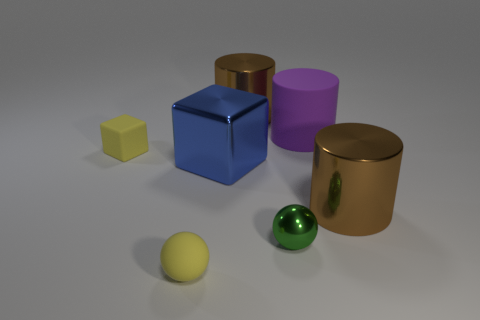What color is the large object that is left of the brown cylinder behind the large brown metallic thing that is in front of the large blue metal object?
Provide a short and direct response. Blue. Is there another purple thing that has the same shape as the purple rubber thing?
Give a very brief answer. No. What number of small red rubber blocks are there?
Give a very brief answer. 0. What is the shape of the large matte thing?
Ensure brevity in your answer.  Cylinder. What number of yellow rubber objects are the same size as the purple thing?
Ensure brevity in your answer.  0. Do the big purple rubber thing and the large blue metallic object have the same shape?
Provide a short and direct response. No. What is the color of the rubber thing that is on the right side of the small yellow object that is on the right side of the small yellow matte block?
Give a very brief answer. Purple. There is a rubber thing that is behind the small yellow ball and to the left of the purple cylinder; what is its size?
Your answer should be compact. Small. Are there any other things that have the same color as the large matte cylinder?
Ensure brevity in your answer.  No. What is the shape of the blue object that is made of the same material as the tiny green sphere?
Keep it short and to the point. Cube. 